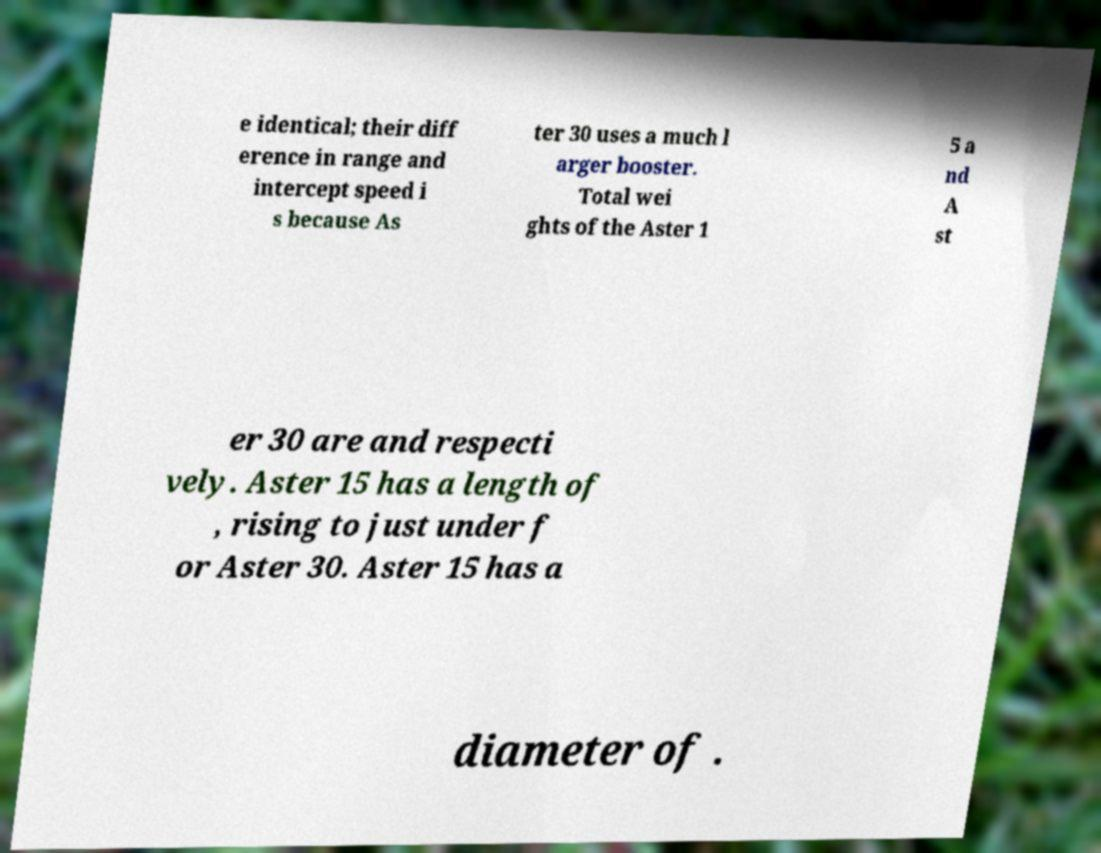Can you read and provide the text displayed in the image?This photo seems to have some interesting text. Can you extract and type it out for me? e identical; their diff erence in range and intercept speed i s because As ter 30 uses a much l arger booster. Total wei ghts of the Aster 1 5 a nd A st er 30 are and respecti vely. Aster 15 has a length of , rising to just under f or Aster 30. Aster 15 has a diameter of . 